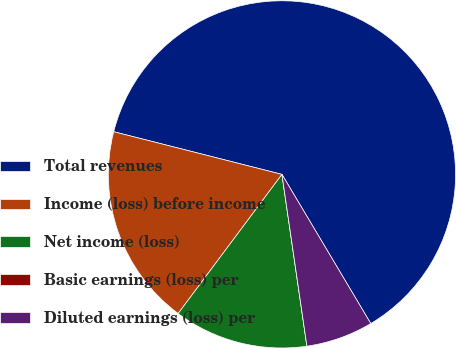Convert chart. <chart><loc_0><loc_0><loc_500><loc_500><pie_chart><fcel>Total revenues<fcel>Income (loss) before income<fcel>Net income (loss)<fcel>Basic earnings (loss) per<fcel>Diluted earnings (loss) per<nl><fcel>62.5%<fcel>18.75%<fcel>12.5%<fcel>0.0%<fcel>6.25%<nl></chart> 